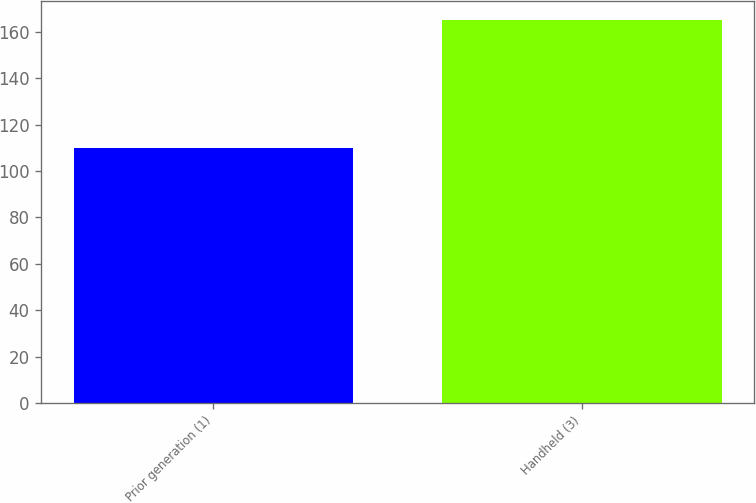<chart> <loc_0><loc_0><loc_500><loc_500><bar_chart><fcel>Prior generation (1)<fcel>Handheld (3)<nl><fcel>110.1<fcel>165.3<nl></chart> 